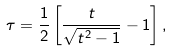<formula> <loc_0><loc_0><loc_500><loc_500>\tau = \frac { 1 } { 2 } \left [ \frac { t } { \sqrt { t ^ { 2 } - 1 } } - 1 \right ] ,</formula> 